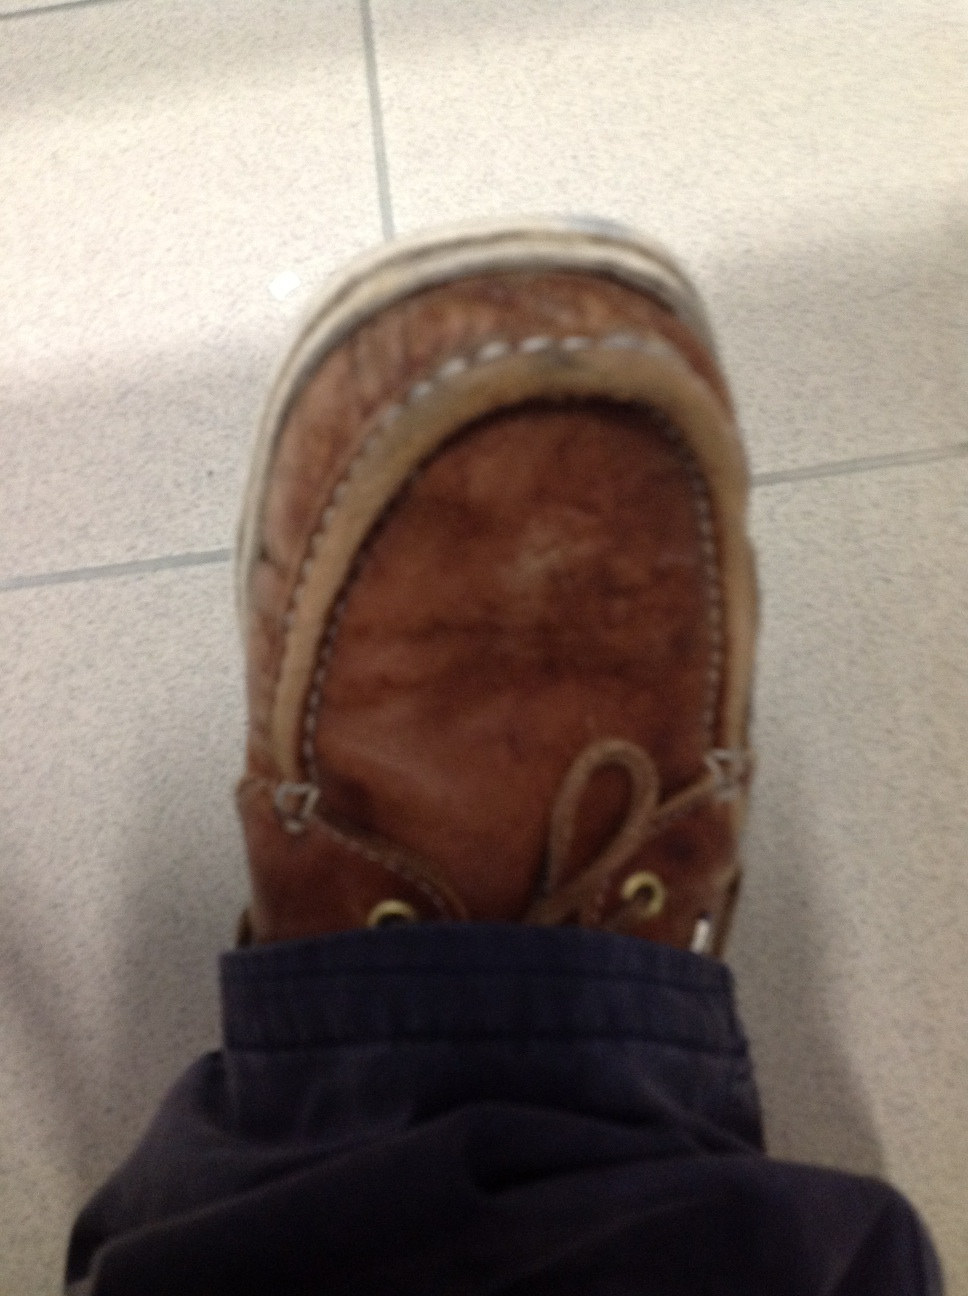Imagine if this shoe could talk. What story would it tell? If this shoe could talk, it would recount tales of wanderings through diverse landscapes - city streets, forest trails, and sandy beaches. It would speak of the countless meetings, both mundane and profound, witnessed from the ground up. It would share the joy of sunny days, the discomfort of rainy afternoons, and the camaraderie of its pair. Each scratch and stain would be a badge of a day well-lived, a journey undertaken. Would this shoe prefer to be in a museum or continue being worn? This shoe, embodying the spirit of adventure and resilience, would likely prefer to continue being worn. For it, every new day brings another journey, another story to add to its collection. It thrives on being a part of its owner's life, enhancing experiences and creating memories. 